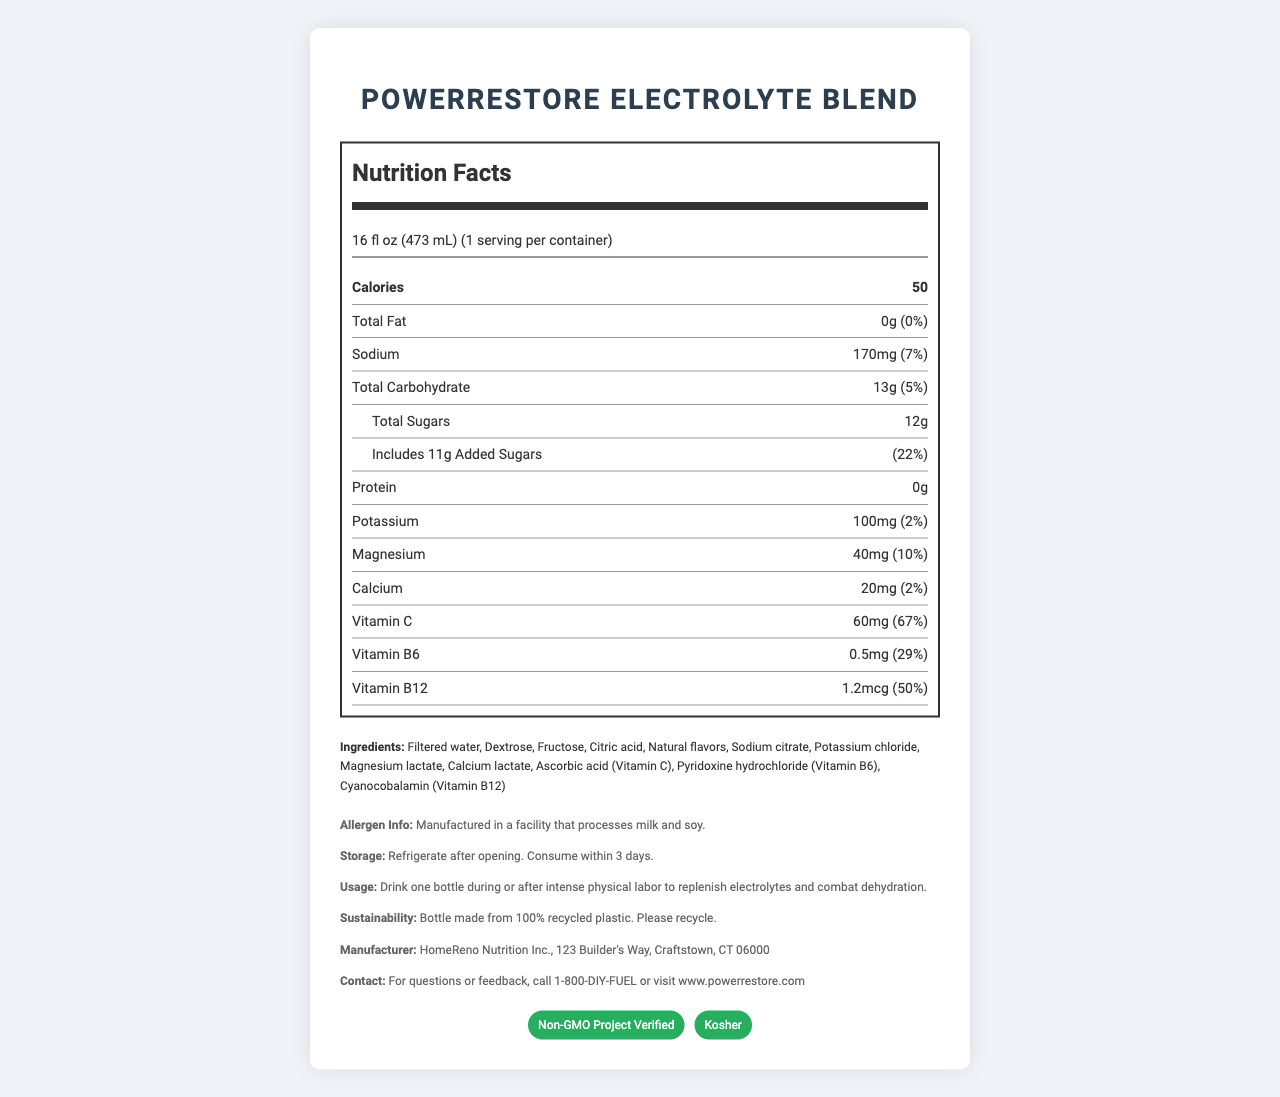what is the serving size of PowerRestore Electrolyte Blend? The serving size is listed under "serving info" in the document.
Answer: 16 fl oz (473 mL) what percentage of the daily value of Vitamin C does one serving provide? It is mentioned next to the amount of Vitamin C under the nutrients section.
Answer: 67% how many grams of added sugars are included in each serving? The added sugars amount is directly listed under the "Total Sugars" section in the document.
Answer: 11g what is the total carbohydrate content for a serving? Total carbohydrate content is listed in the nutrients section under "Total Carbohydrate."
Answer: 13g what is the daily value percentage of sodium in this drink? The daily value for sodium is mentioned next to its amount in the nutrients section.
Answer: 7% how many certifications does PowerRestore Electrolyte Blend have? The product has two certifications listed: "Non-GMO Project Verified" and "Kosher."
Answer: 2 what is the main source of sweetness in this drink? A. Stevia B. Dextrose and Fructose C. Sucralose D. Aspartame The ingredients list mentions Dextrose and Fructose as the main sources of sweetness.
Answer: B. Dextrose and Fructose what is the recommended usage instruction for this product? The usage instruction can be found in the additional information section.
Answer: Drink one bottle during or after intense physical labor to replenish electrolytes and combat dehydration. which ingredient acts as a source of potassium in the drink? The ingredient list, along with the potassium content, shows that potassium chloride is a source.
Answer: Potassium chloride which company manufactures PowerRestore Electrolyte Blend? A. PowerNutrition B. DIY Nutrition C. HomeReno Nutrition Inc. D. Crafts Nutrition The manufacturer's name is provided in the additional info section.
Answer: C. HomeReno Nutrition Inc. is this product non-GMO? The certification section lists "Non-GMO Project Verified," confirming it is non-GMO.
Answer: Yes how should you store PowerRestore Electrolyte Blend after opening? Detailed storage instructions are given in the additional information section.
Answer: Refrigerate after opening. Consume within 3 days. does this drink contain any protein? The nutrients section lists "Protein" as 0g.
Answer: No summarize the main nutritional benefits of PowerRestore Electrolyte Blend. This description covers the overall nutritional benefits, highlighting its purpose, key nutrients, and certifications.
Answer: PowerRestore Electrolyte Blend is a low-calorie drink designed to help replenish electrolytes lost during intense physical activities. It contains key electrolytes such as sodium, potassium, and magnesium, as well as important vitamins like Vitamin C, Vitamin B6, and Vitamin B12. This drink also includes some added sugars and is non-GMO and kosher certified. what kind of facility is PowerRestore Electrolyte Blend manufactured in? While the document specifies that the product is manufactured in a facility that processes milk and soy, it does not provide detailed information about the facility type itself.
Answer: I don't know 